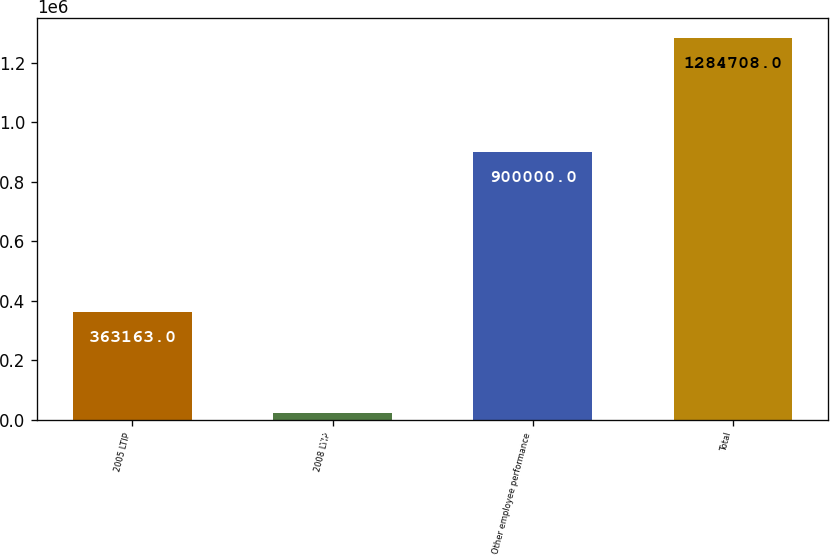Convert chart to OTSL. <chart><loc_0><loc_0><loc_500><loc_500><bar_chart><fcel>2005 LTIP<fcel>2008 LTIP<fcel>Other employee performance<fcel>Total<nl><fcel>363163<fcel>21545<fcel>900000<fcel>1.28471e+06<nl></chart> 